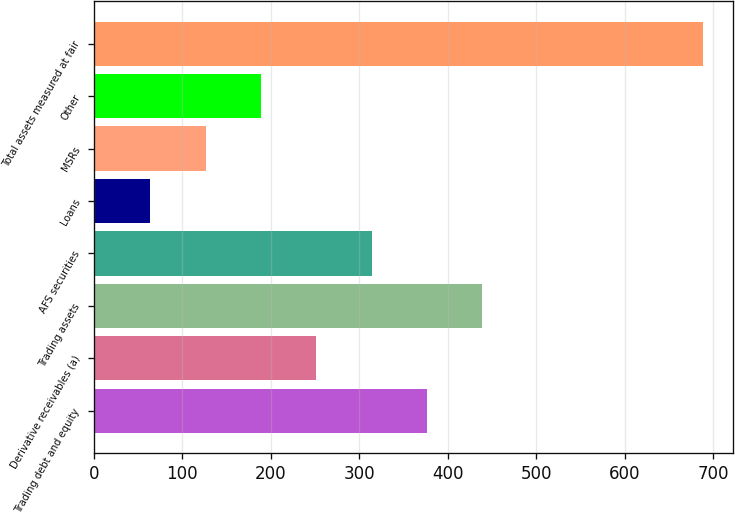Convert chart to OTSL. <chart><loc_0><loc_0><loc_500><loc_500><bar_chart><fcel>Trading debt and equity<fcel>Derivative receivables (a)<fcel>Trading assets<fcel>AFS securities<fcel>Loans<fcel>MSRs<fcel>Other<fcel>Total assets measured at fair<nl><fcel>376.72<fcel>251.58<fcel>439.29<fcel>314.15<fcel>63.87<fcel>126.44<fcel>189.01<fcel>688.27<nl></chart> 